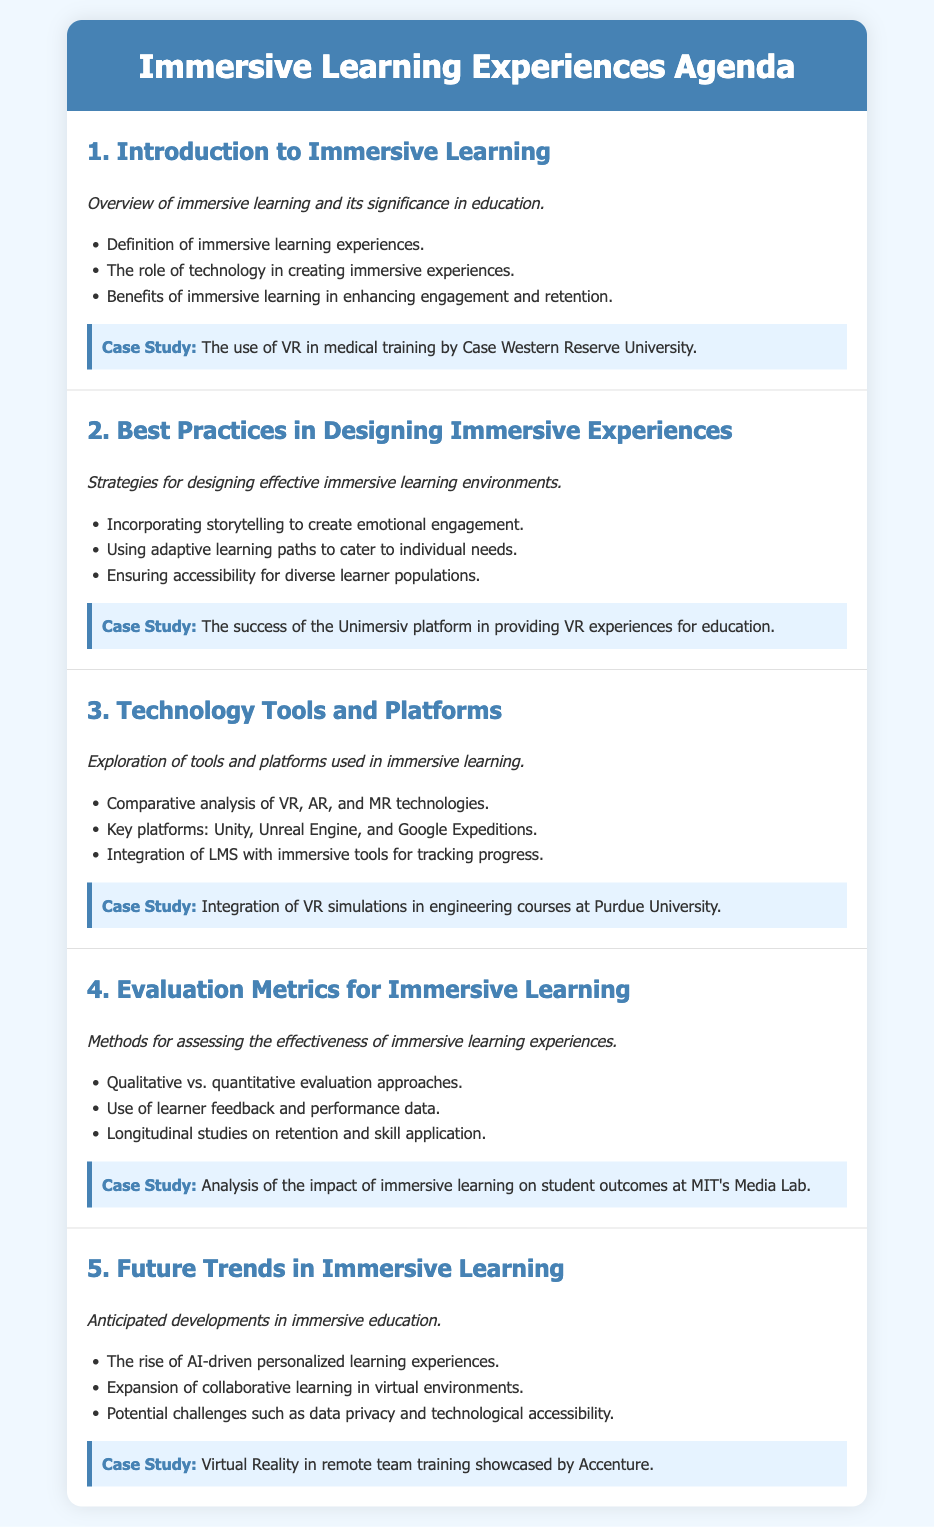What is the title of the agenda? The title of the agenda is presented in the header of the document.
Answer: Immersive Learning Experiences Agenda Who is highlighted in the case study for VR in medical training? The case study mentions a specific university known for its innovative use of VR in medical training.
Answer: Case Western Reserve University What is one of the best practices in designing immersive experiences? The document provides a list of effective strategies for creating immersive learning environments.
Answer: Incorporating storytelling Which platform is mentioned for providing VR experiences in education? The agenda lists a specific platform that has achieved success in offering VR educational experiences.
Answer: Unimersiv In which university is VR simulations integrated into engineering courses? The document refers to a university that employs VR in its engineering curriculum.
Answer: Purdue University What type of evaluation approaches are discussed? The agenda outlines two main types of evaluation methods for assessing immersive learning experiences.
Answer: Qualitative and quantitative What is a future trend anticipated in immersive learning? The document mentions a specific development expected to impact the future landscape of immersive education.
Answer: AI-driven personalized learning experiences Who is showcased for virtual reality in remote team training? The agenda includes a case study highlighting an organization's use of VR for team training.
Answer: Accenture 